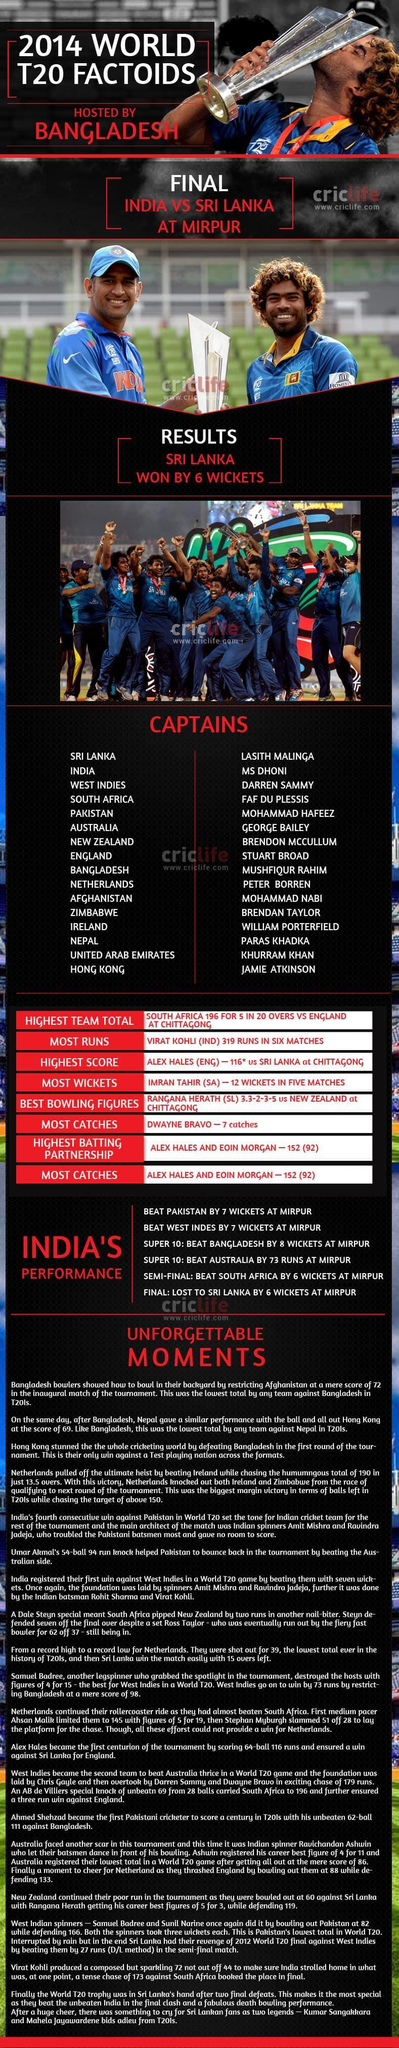Alex Hales belongs to which country
Answer the question with a short phrase. Eng In India's performance highlights, all the matches were held where Mirpur Which 2 captains are holding the cup Lasith Malinga, MS Dhoni Whom did Sri Lanka defeat India Which captain is kissing the cup Lasith Malinga Alex Hales and Eoin Morgan were awarded for which all categories Highest batting partnership, Most catches 